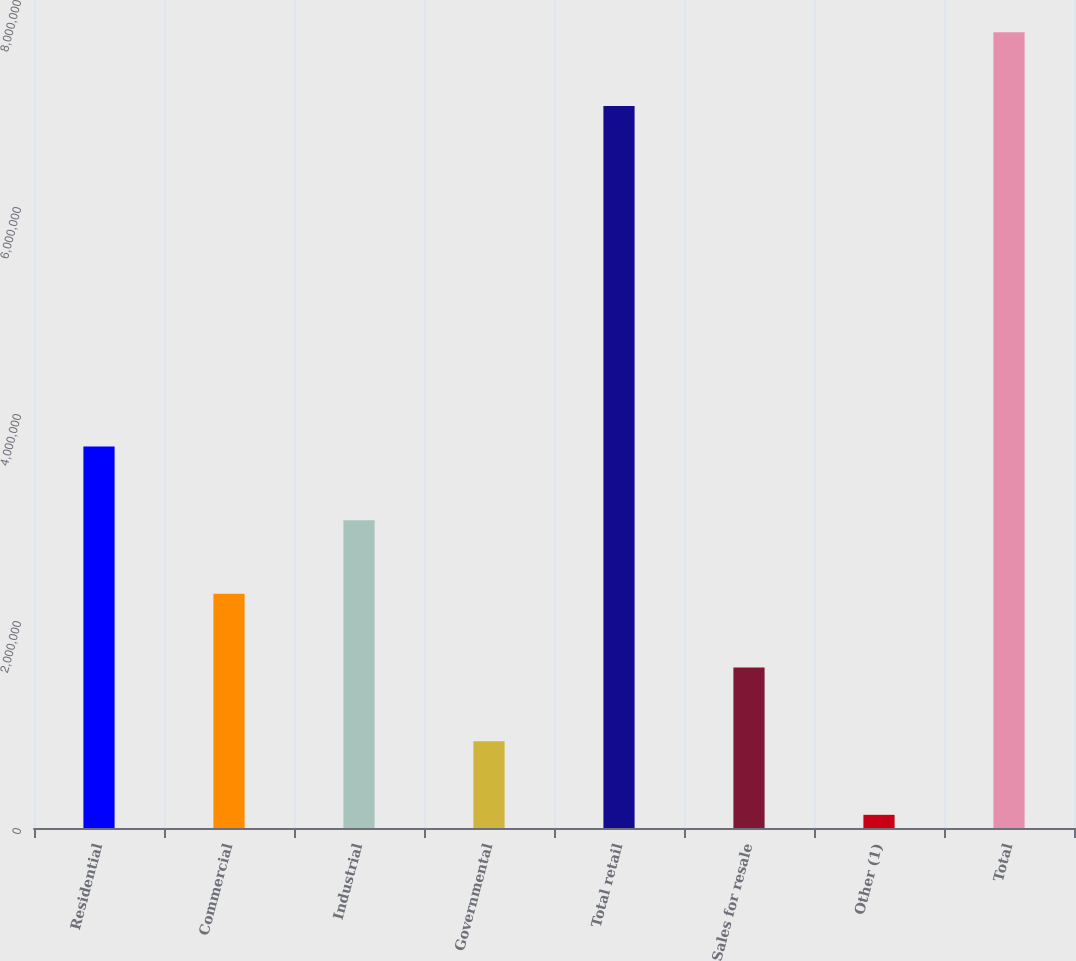Convert chart. <chart><loc_0><loc_0><loc_500><loc_500><bar_chart><fcel>Residential<fcel>Commercial<fcel>Industrial<fcel>Governmental<fcel>Total retail<fcel>Sales for resale<fcel>Other (1)<fcel>Total<nl><fcel>3.68608e+06<fcel>2.26258e+06<fcel>2.97433e+06<fcel>839083<fcel>6.97681e+06<fcel>1.55083e+06<fcel>127334<fcel>7.68856e+06<nl></chart> 